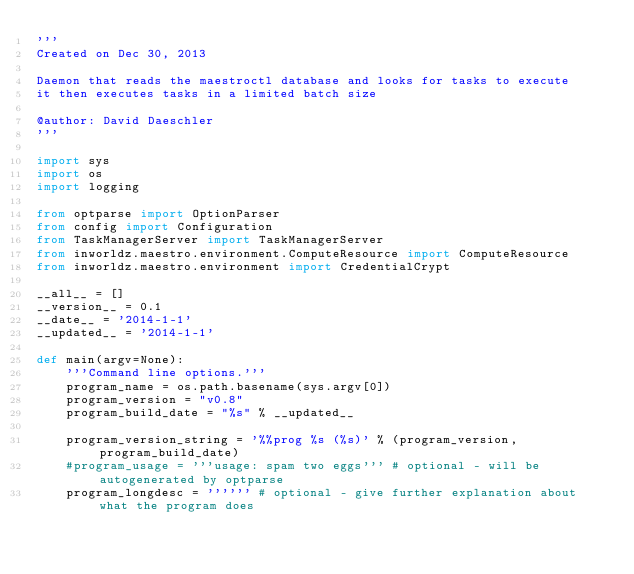<code> <loc_0><loc_0><loc_500><loc_500><_Python_>'''
Created on Dec 30, 2013

Daemon that reads the maestroctl database and looks for tasks to execute
it then executes tasks in a limited batch size

@author: David Daeschler
'''

import sys
import os
import logging

from optparse import OptionParser
from config import Configuration
from TaskManagerServer import TaskManagerServer
from inworldz.maestro.environment.ComputeResource import ComputeResource
from inworldz.maestro.environment import CredentialCrypt

__all__ = []
__version__ = 0.1
__date__ = '2014-1-1'
__updated__ = '2014-1-1'

def main(argv=None):
    '''Command line options.'''
    program_name = os.path.basename(sys.argv[0])
    program_version = "v0.8"
    program_build_date = "%s" % __updated__

    program_version_string = '%%prog %s (%s)' % (program_version, program_build_date)
    #program_usage = '''usage: spam two eggs''' # optional - will be autogenerated by optparse
    program_longdesc = '''''' # optional - give further explanation about what the program does</code> 